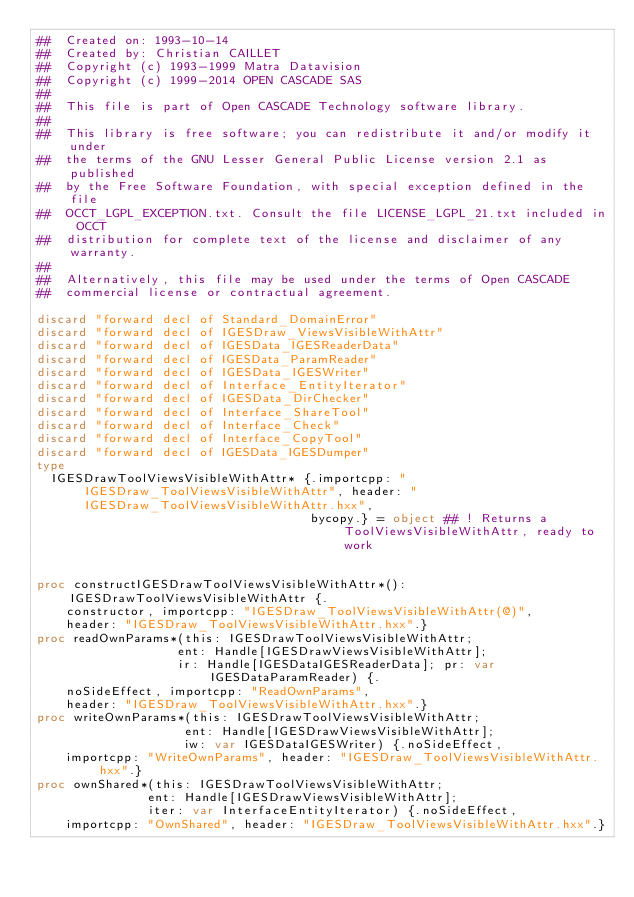<code> <loc_0><loc_0><loc_500><loc_500><_Nim_>##  Created on: 1993-10-14
##  Created by: Christian CAILLET
##  Copyright (c) 1993-1999 Matra Datavision
##  Copyright (c) 1999-2014 OPEN CASCADE SAS
##
##  This file is part of Open CASCADE Technology software library.
##
##  This library is free software; you can redistribute it and/or modify it under
##  the terms of the GNU Lesser General Public License version 2.1 as published
##  by the Free Software Foundation, with special exception defined in the file
##  OCCT_LGPL_EXCEPTION.txt. Consult the file LICENSE_LGPL_21.txt included in OCCT
##  distribution for complete text of the license and disclaimer of any warranty.
##
##  Alternatively, this file may be used under the terms of Open CASCADE
##  commercial license or contractual agreement.

discard "forward decl of Standard_DomainError"
discard "forward decl of IGESDraw_ViewsVisibleWithAttr"
discard "forward decl of IGESData_IGESReaderData"
discard "forward decl of IGESData_ParamReader"
discard "forward decl of IGESData_IGESWriter"
discard "forward decl of Interface_EntityIterator"
discard "forward decl of IGESData_DirChecker"
discard "forward decl of Interface_ShareTool"
discard "forward decl of Interface_Check"
discard "forward decl of Interface_CopyTool"
discard "forward decl of IGESData_IGESDumper"
type
  IGESDrawToolViewsVisibleWithAttr* {.importcpp: "IGESDraw_ToolViewsVisibleWithAttr", header: "IGESDraw_ToolViewsVisibleWithAttr.hxx",
                                     bycopy.} = object ## ! Returns a ToolViewsVisibleWithAttr, ready to work


proc constructIGESDrawToolViewsVisibleWithAttr*(): IGESDrawToolViewsVisibleWithAttr {.
    constructor, importcpp: "IGESDraw_ToolViewsVisibleWithAttr(@)",
    header: "IGESDraw_ToolViewsVisibleWithAttr.hxx".}
proc readOwnParams*(this: IGESDrawToolViewsVisibleWithAttr;
                   ent: Handle[IGESDrawViewsVisibleWithAttr];
                   ir: Handle[IGESDataIGESReaderData]; pr: var IGESDataParamReader) {.
    noSideEffect, importcpp: "ReadOwnParams",
    header: "IGESDraw_ToolViewsVisibleWithAttr.hxx".}
proc writeOwnParams*(this: IGESDrawToolViewsVisibleWithAttr;
                    ent: Handle[IGESDrawViewsVisibleWithAttr];
                    iw: var IGESDataIGESWriter) {.noSideEffect,
    importcpp: "WriteOwnParams", header: "IGESDraw_ToolViewsVisibleWithAttr.hxx".}
proc ownShared*(this: IGESDrawToolViewsVisibleWithAttr;
               ent: Handle[IGESDrawViewsVisibleWithAttr];
               iter: var InterfaceEntityIterator) {.noSideEffect,
    importcpp: "OwnShared", header: "IGESDraw_ToolViewsVisibleWithAttr.hxx".}</code> 